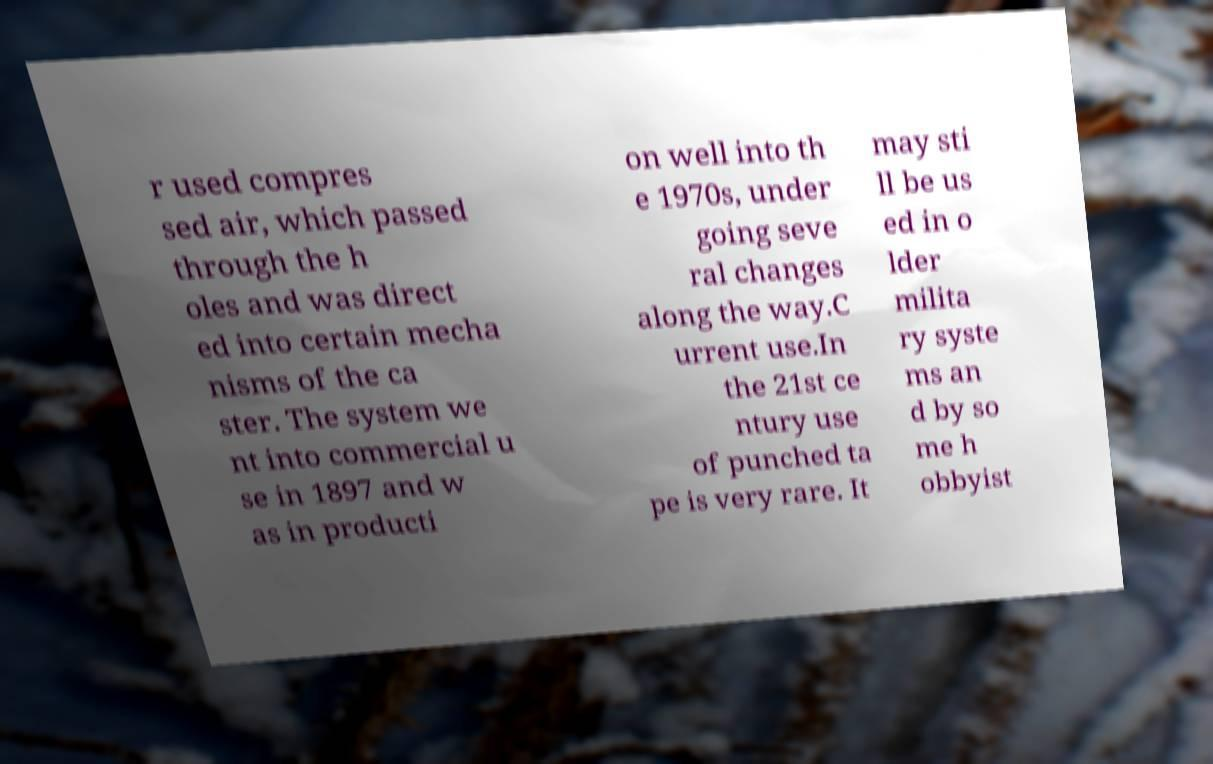For documentation purposes, I need the text within this image transcribed. Could you provide that? r used compres sed air, which passed through the h oles and was direct ed into certain mecha nisms of the ca ster. The system we nt into commercial u se in 1897 and w as in producti on well into th e 1970s, under going seve ral changes along the way.C urrent use.In the 21st ce ntury use of punched ta pe is very rare. It may sti ll be us ed in o lder milita ry syste ms an d by so me h obbyist 